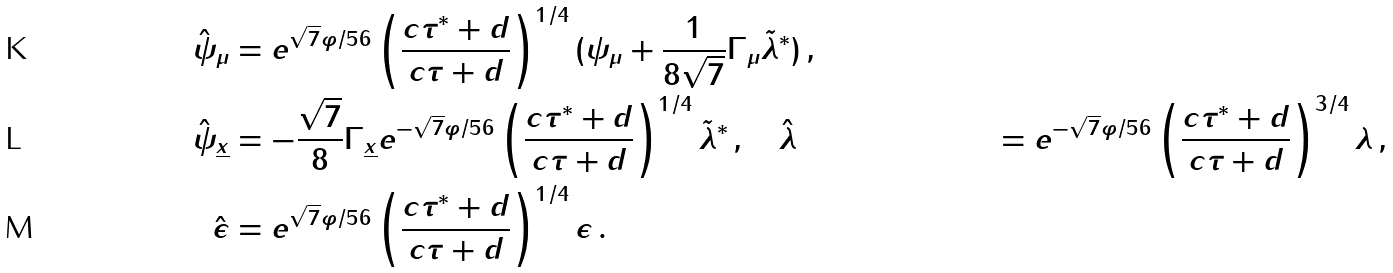Convert formula to latex. <formula><loc_0><loc_0><loc_500><loc_500>\hat { \psi } _ { \mu } & = e ^ { \sqrt { 7 } \varphi / 5 6 } \left ( \frac { c \tau ^ { * } + d } { c \tau + d } \right ) ^ { 1 / 4 } ( \psi _ { \mu } + \frac { 1 } { 8 \sqrt { 7 } } \Gamma _ { \mu } \tilde { \lambda } ^ { * } ) \, , \\ \hat { \psi } _ { \underline { x } } & = - \frac { \sqrt { 7 } } { 8 } \Gamma _ { \underline { x } } e ^ { - \sqrt { 7 } \varphi / 5 6 } \left ( \frac { c \tau ^ { * } + d } { c \tau + d } \right ) ^ { 1 / 4 } \tilde { \lambda } ^ { * } \, , \quad \hat { \lambda } & = e ^ { - \sqrt { 7 } \varphi / 5 6 } \left ( \frac { c \tau ^ { * } + d } { c \tau + d } \right ) ^ { 3 / 4 } \lambda \, , \\ \hat { \epsilon } & = e ^ { \sqrt { 7 } \varphi / 5 6 } \left ( \frac { c \tau ^ { * } + d } { c \tau + d } \right ) ^ { 1 / 4 } \epsilon \, .</formula> 